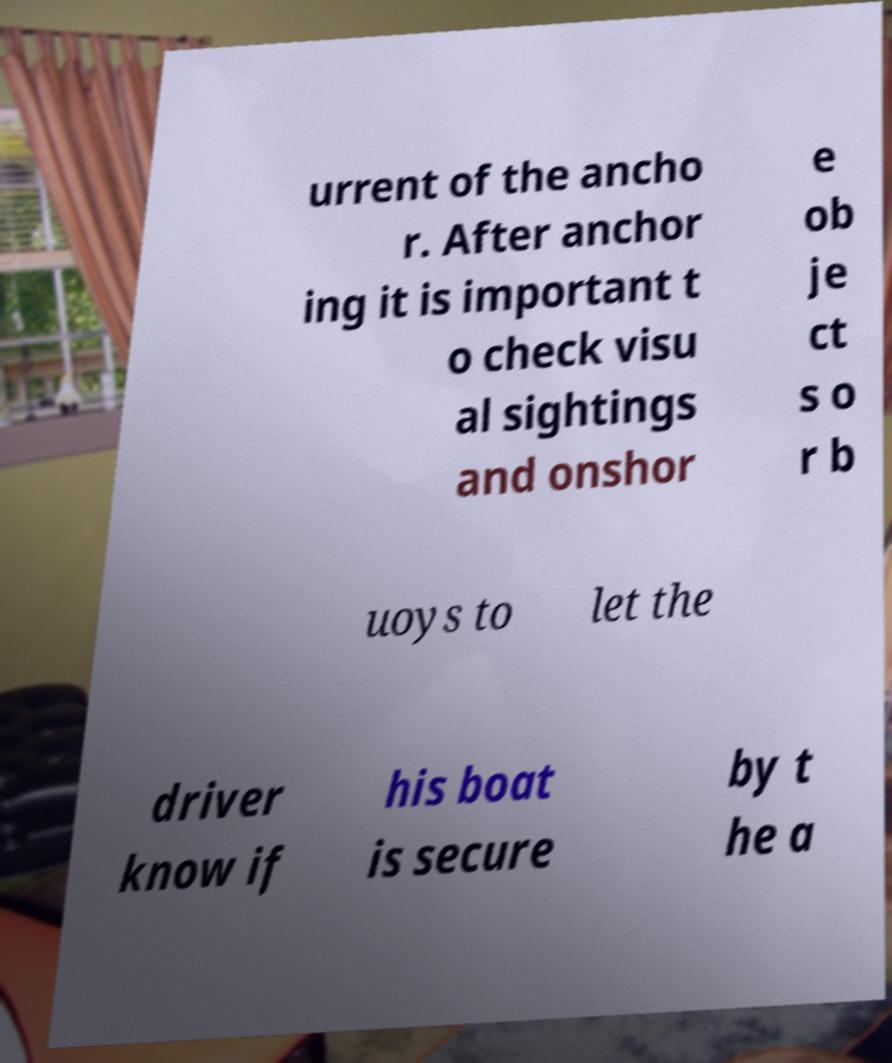Can you accurately transcribe the text from the provided image for me? urrent of the ancho r. After anchor ing it is important t o check visu al sightings and onshor e ob je ct s o r b uoys to let the driver know if his boat is secure by t he a 